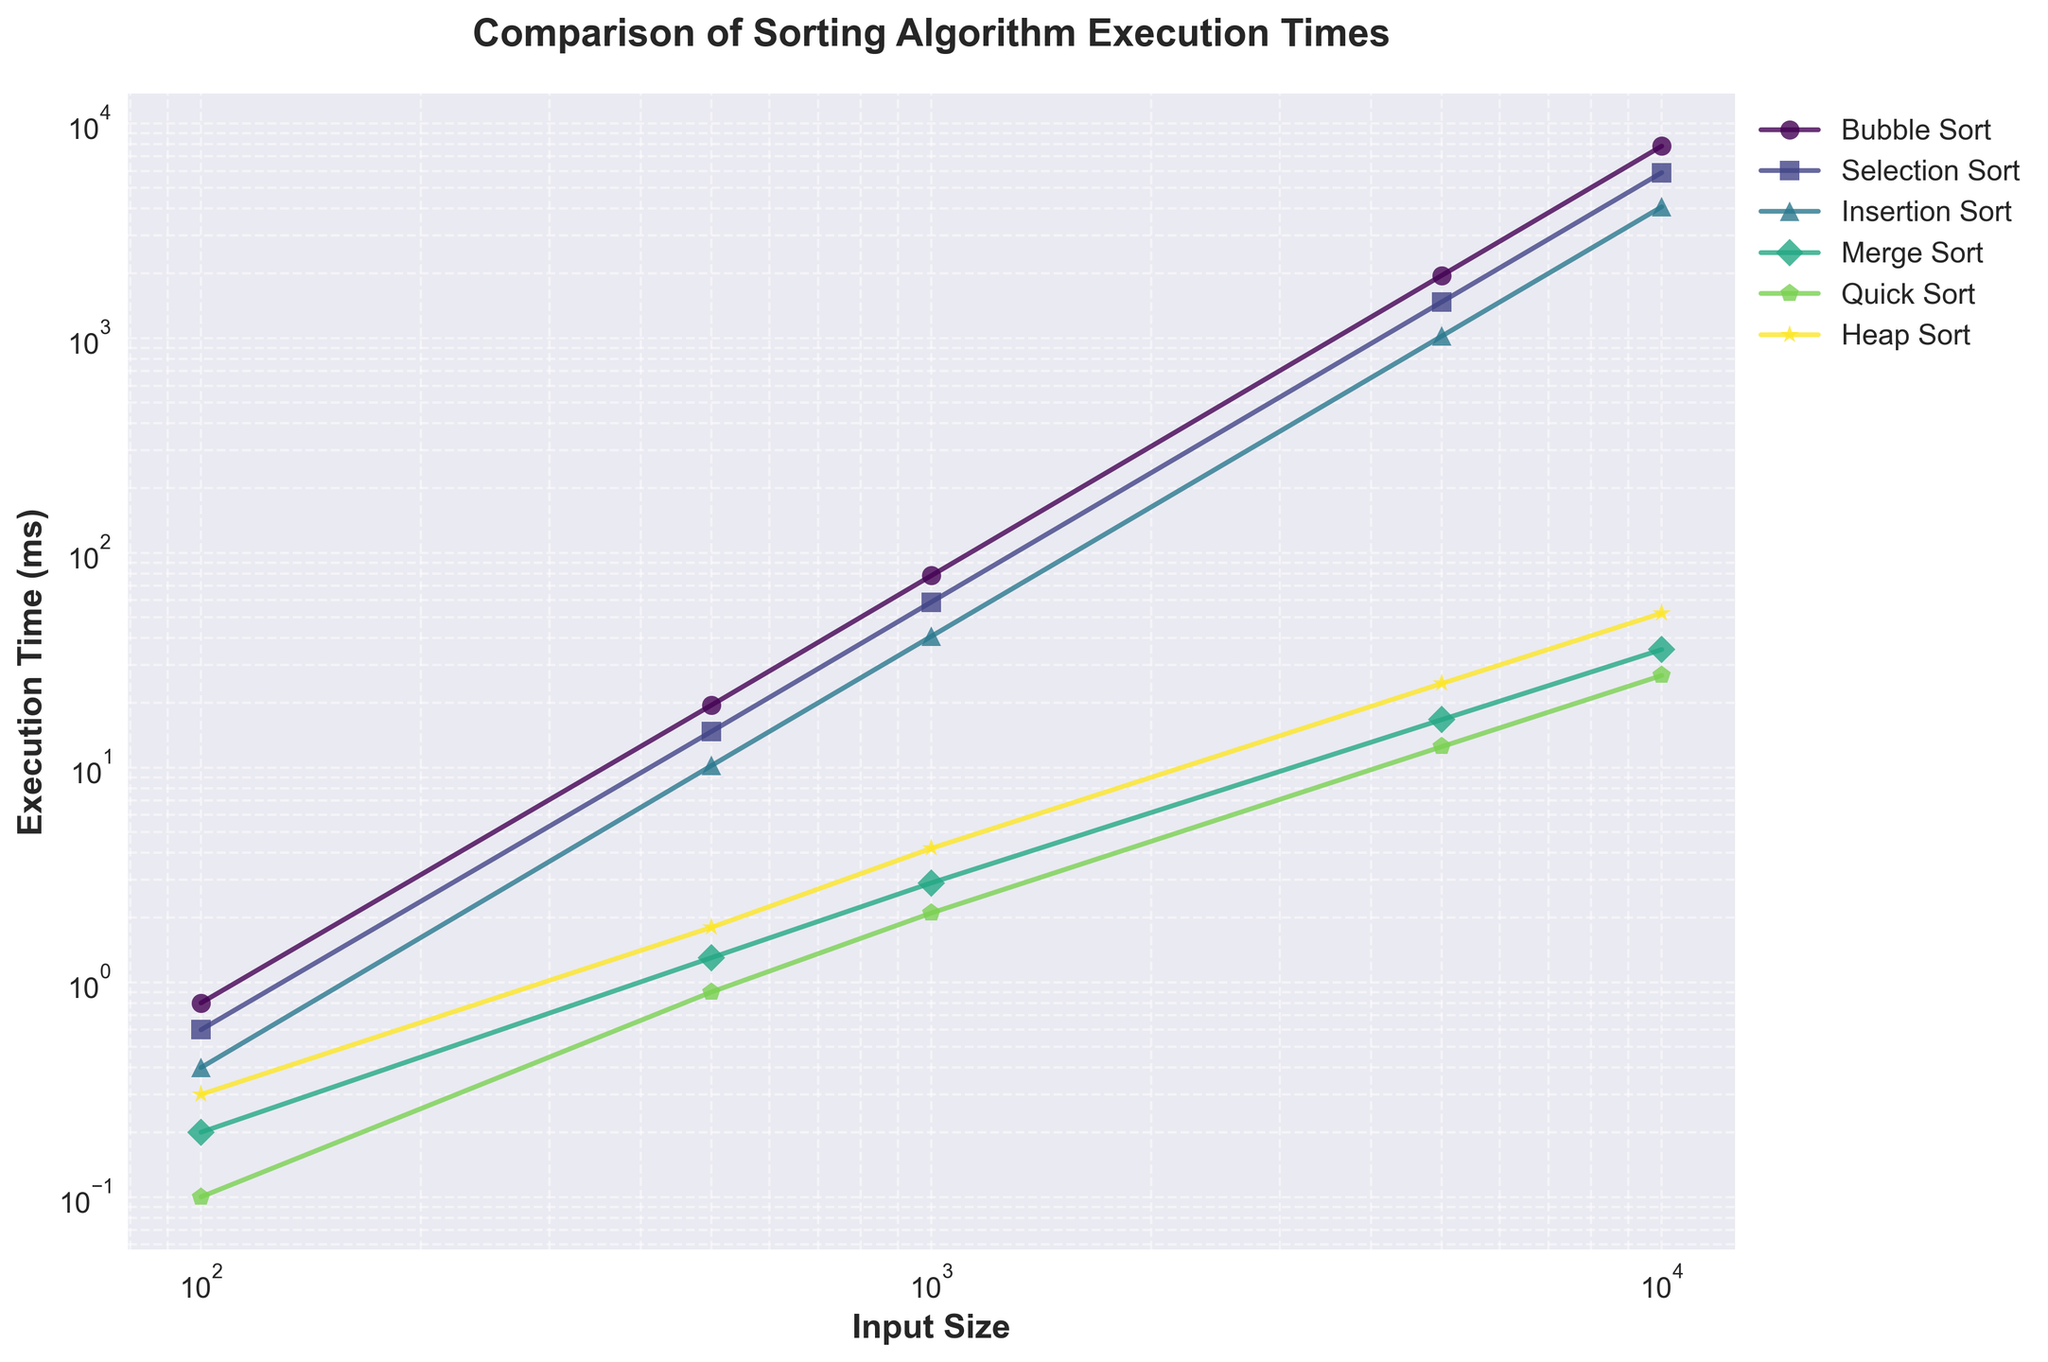What sorting algorithm has the shortest execution time for the largest input size? First, identify the largest input size, which is 10,000. Then look for the execution times of each sorting algorithm at this input size and find the minimum. Quick Sort has the lowest execution time of 26.8 ms.
Answer: Quick Sort Which sorting algorithm's execution time grows fastest as input size increases? Compare the slopes of the lines for each sorting algorithm. Bubble Sort demonstrates the steepest increase in execution time, indicating it grows the fastest.
Answer: Bubble Sort At an input size of 1000, which two sorting algorithms have the closest execution times? Look at the execution times for each sorting algorithm at an input size of 1000 and find the pair with the smallest difference. Merge Sort (2.9 ms) and Quick Sort (2.1 ms) have execution times that are closest to each other.
Answer: Merge Sort and Quick Sort How much faster is Quick Sort compared to Heap Sort at an input size of 5000? Compare the execution times of Quick Sort and Heap Sort at an input size of 5000 and find the difference. Quick Sort: 12.5 ms, Heap Sort: 24.6 ms, so 24.6 ms - 12.5 ms = 12.1 ms.
Answer: 12.1 ms Which sorting algorithm remains below 1 ms execution time the longest? Identify the input size thresholds where each algorithm’s execution time exceeds 1 ms. Quick Sort remains below 1 ms up to an input size of 500.
Answer: Quick Sort What is the average execution time of Insertion Sort over all input sizes? Calculate the sum of all execution times for Insertion Sort and divide by the number of data points. (0.4 + 10.2 + 40.8 + 1020.3 + 4081.2) / 5 = 1030.58 ms.
Answer: 1030.58 ms At an input size of 500, by what factor is Merge Sort faster than Bubble Sort? Compare the execution times of Bubble Sort and Merge Sort at input size 500. Bubble Sort: 19.5 ms, Merge Sort: 1.3 ms. The factor is 19.5 / 1.3 ≈ 15.
Answer: ≈ 15 Which algorithm has the smallest difference in execution time between the 100 and 10000 input sizes? Calculate the differences for each algorithm between the 100 and 10000 input sizes and identify the smallest one. Quick Sort: 26.7 ms (26.8 - 0.1 = 26.7).
Answer: Quick Sort Between Bubble Sort and Selection Sort, which one performs better for smaller inputs, and which for larger inputs? Compare their execution times for smaller inputs (100, 500) and larger inputs (5000, 10000). For small inputs (100, 500), Selection Sort performs better. For large inputs (5000, 10000), Selection Sort still performs better.
Answer: Selection Sort, Selection Sort 